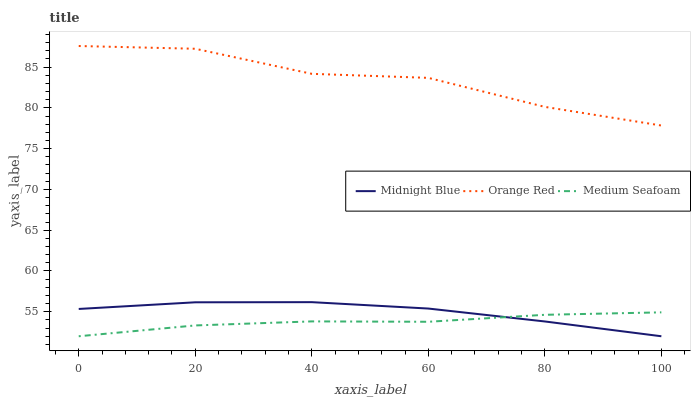Does Medium Seafoam have the minimum area under the curve?
Answer yes or no. Yes. Does Orange Red have the maximum area under the curve?
Answer yes or no. Yes. Does Midnight Blue have the minimum area under the curve?
Answer yes or no. No. Does Midnight Blue have the maximum area under the curve?
Answer yes or no. No. Is Midnight Blue the smoothest?
Answer yes or no. Yes. Is Orange Red the roughest?
Answer yes or no. Yes. Is Orange Red the smoothest?
Answer yes or no. No. Is Midnight Blue the roughest?
Answer yes or no. No. Does Medium Seafoam have the lowest value?
Answer yes or no. Yes. Does Orange Red have the lowest value?
Answer yes or no. No. Does Orange Red have the highest value?
Answer yes or no. Yes. Does Midnight Blue have the highest value?
Answer yes or no. No. Is Medium Seafoam less than Orange Red?
Answer yes or no. Yes. Is Orange Red greater than Medium Seafoam?
Answer yes or no. Yes. Does Medium Seafoam intersect Midnight Blue?
Answer yes or no. Yes. Is Medium Seafoam less than Midnight Blue?
Answer yes or no. No. Is Medium Seafoam greater than Midnight Blue?
Answer yes or no. No. Does Medium Seafoam intersect Orange Red?
Answer yes or no. No. 